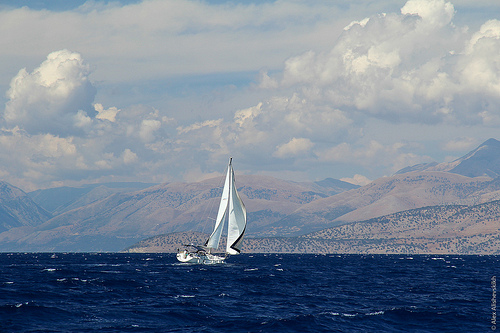How many boats? There is one boat visible in the image. It is a sailboat cutting through the water with its sails fully unfurled, indicating a strong wind and good sailing conditions. The boat is navigating the open sea with a backdrop of mountains under a partly cloudy sky. 